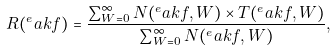Convert formula to latex. <formula><loc_0><loc_0><loc_500><loc_500>R ( ^ { e } a k f ) = \frac { \sum _ { W = 0 } ^ { \infty } N ( ^ { e } a k f , W ) \times T ( ^ { e } a k f , W ) } { \sum _ { W = 0 } ^ { \infty } N ( ^ { e } a k f , W ) } ,</formula> 